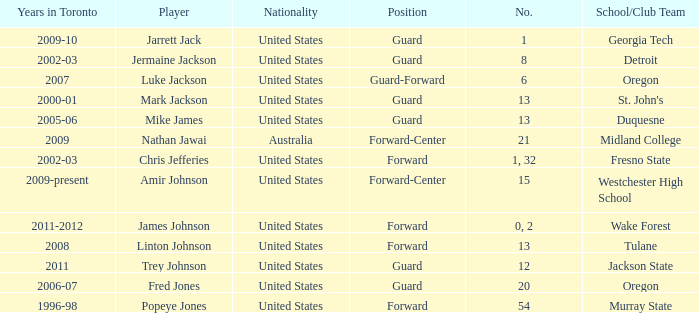What school/club team is Trey Johnson on? Jackson State. Parse the table in full. {'header': ['Years in Toronto', 'Player', 'Nationality', 'Position', 'No.', 'School/Club Team'], 'rows': [['2009-10', 'Jarrett Jack', 'United States', 'Guard', '1', 'Georgia Tech'], ['2002-03', 'Jermaine Jackson', 'United States', 'Guard', '8', 'Detroit'], ['2007', 'Luke Jackson', 'United States', 'Guard-Forward', '6', 'Oregon'], ['2000-01', 'Mark Jackson', 'United States', 'Guard', '13', "St. John's"], ['2005-06', 'Mike James', 'United States', 'Guard', '13', 'Duquesne'], ['2009', 'Nathan Jawai', 'Australia', 'Forward-Center', '21', 'Midland College'], ['2002-03', 'Chris Jefferies', 'United States', 'Forward', '1, 32', 'Fresno State'], ['2009-present', 'Amir Johnson', 'United States', 'Forward-Center', '15', 'Westchester High School'], ['2011-2012', 'James Johnson', 'United States', 'Forward', '0, 2', 'Wake Forest'], ['2008', 'Linton Johnson', 'United States', 'Forward', '13', 'Tulane'], ['2011', 'Trey Johnson', 'United States', 'Guard', '12', 'Jackson State'], ['2006-07', 'Fred Jones', 'United States', 'Guard', '20', 'Oregon'], ['1996-98', 'Popeye Jones', 'United States', 'Forward', '54', 'Murray State']]} 